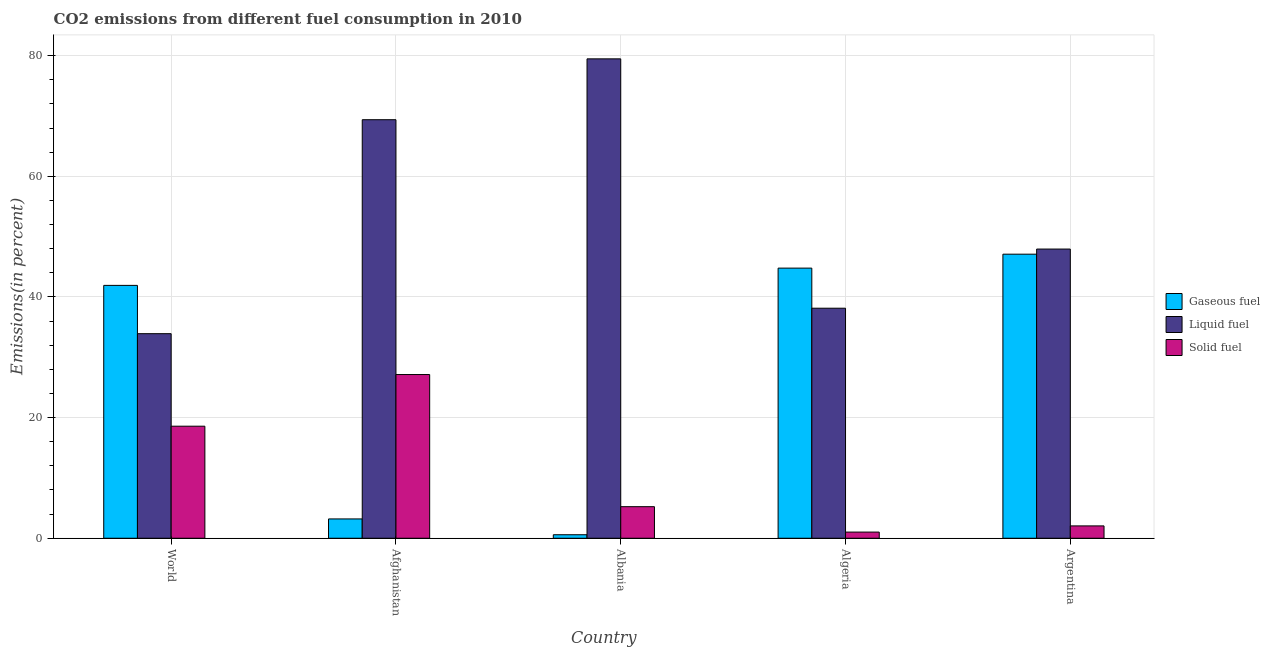How many groups of bars are there?
Provide a short and direct response. 5. Are the number of bars on each tick of the X-axis equal?
Make the answer very short. Yes. What is the percentage of gaseous fuel emission in Argentina?
Ensure brevity in your answer.  47.1. Across all countries, what is the maximum percentage of liquid fuel emission?
Offer a terse response. 79.49. Across all countries, what is the minimum percentage of gaseous fuel emission?
Offer a very short reply. 0.58. In which country was the percentage of solid fuel emission maximum?
Your answer should be compact. Afghanistan. In which country was the percentage of liquid fuel emission minimum?
Your answer should be compact. World. What is the total percentage of liquid fuel emission in the graph?
Offer a very short reply. 268.88. What is the difference between the percentage of gaseous fuel emission in Albania and that in Algeria?
Offer a very short reply. -44.21. What is the difference between the percentage of solid fuel emission in Argentina and the percentage of gaseous fuel emission in Albania?
Keep it short and to the point. 1.47. What is the average percentage of gaseous fuel emission per country?
Keep it short and to the point. 27.52. What is the difference between the percentage of liquid fuel emission and percentage of gaseous fuel emission in World?
Provide a succinct answer. -8.01. What is the ratio of the percentage of liquid fuel emission in Afghanistan to that in Algeria?
Keep it short and to the point. 1.82. Is the difference between the percentage of liquid fuel emission in Albania and World greater than the difference between the percentage of gaseous fuel emission in Albania and World?
Offer a terse response. Yes. What is the difference between the highest and the second highest percentage of gaseous fuel emission?
Give a very brief answer. 2.31. What is the difference between the highest and the lowest percentage of liquid fuel emission?
Offer a very short reply. 45.57. What does the 1st bar from the left in Algeria represents?
Offer a terse response. Gaseous fuel. What does the 1st bar from the right in Afghanistan represents?
Your response must be concise. Solid fuel. Are all the bars in the graph horizontal?
Your answer should be compact. No. How many countries are there in the graph?
Offer a terse response. 5. Does the graph contain any zero values?
Your response must be concise. No. Does the graph contain grids?
Your response must be concise. Yes. How are the legend labels stacked?
Your answer should be very brief. Vertical. What is the title of the graph?
Your response must be concise. CO2 emissions from different fuel consumption in 2010. Does "Ages 15-20" appear as one of the legend labels in the graph?
Offer a very short reply. No. What is the label or title of the X-axis?
Keep it short and to the point. Country. What is the label or title of the Y-axis?
Keep it short and to the point. Emissions(in percent). What is the Emissions(in percent) in Gaseous fuel in World?
Offer a terse response. 41.93. What is the Emissions(in percent) in Liquid fuel in World?
Provide a short and direct response. 33.92. What is the Emissions(in percent) in Solid fuel in World?
Offer a terse response. 18.58. What is the Emissions(in percent) of Gaseous fuel in Afghanistan?
Ensure brevity in your answer.  3.2. What is the Emissions(in percent) of Liquid fuel in Afghanistan?
Ensure brevity in your answer.  69.39. What is the Emissions(in percent) of Solid fuel in Afghanistan?
Give a very brief answer. 27.14. What is the Emissions(in percent) of Gaseous fuel in Albania?
Provide a succinct answer. 0.58. What is the Emissions(in percent) of Liquid fuel in Albania?
Offer a terse response. 79.49. What is the Emissions(in percent) of Solid fuel in Albania?
Keep it short and to the point. 5.23. What is the Emissions(in percent) in Gaseous fuel in Algeria?
Provide a short and direct response. 44.79. What is the Emissions(in percent) in Liquid fuel in Algeria?
Make the answer very short. 38.14. What is the Emissions(in percent) of Solid fuel in Algeria?
Give a very brief answer. 1.02. What is the Emissions(in percent) in Gaseous fuel in Argentina?
Provide a succinct answer. 47.1. What is the Emissions(in percent) in Liquid fuel in Argentina?
Your response must be concise. 47.95. What is the Emissions(in percent) of Solid fuel in Argentina?
Give a very brief answer. 2.05. Across all countries, what is the maximum Emissions(in percent) in Gaseous fuel?
Your response must be concise. 47.1. Across all countries, what is the maximum Emissions(in percent) of Liquid fuel?
Give a very brief answer. 79.49. Across all countries, what is the maximum Emissions(in percent) of Solid fuel?
Keep it short and to the point. 27.14. Across all countries, what is the minimum Emissions(in percent) in Gaseous fuel?
Offer a terse response. 0.58. Across all countries, what is the minimum Emissions(in percent) in Liquid fuel?
Give a very brief answer. 33.92. Across all countries, what is the minimum Emissions(in percent) of Solid fuel?
Provide a short and direct response. 1.02. What is the total Emissions(in percent) in Gaseous fuel in the graph?
Offer a terse response. 137.6. What is the total Emissions(in percent) in Liquid fuel in the graph?
Offer a terse response. 268.88. What is the total Emissions(in percent) of Solid fuel in the graph?
Your answer should be compact. 54.02. What is the difference between the Emissions(in percent) in Gaseous fuel in World and that in Afghanistan?
Offer a very short reply. 38.72. What is the difference between the Emissions(in percent) of Liquid fuel in World and that in Afghanistan?
Provide a succinct answer. -35.48. What is the difference between the Emissions(in percent) in Solid fuel in World and that in Afghanistan?
Your answer should be very brief. -8.57. What is the difference between the Emissions(in percent) in Gaseous fuel in World and that in Albania?
Your response must be concise. 41.34. What is the difference between the Emissions(in percent) of Liquid fuel in World and that in Albania?
Keep it short and to the point. -45.57. What is the difference between the Emissions(in percent) of Solid fuel in World and that in Albania?
Keep it short and to the point. 13.35. What is the difference between the Emissions(in percent) of Gaseous fuel in World and that in Algeria?
Provide a succinct answer. -2.86. What is the difference between the Emissions(in percent) of Liquid fuel in World and that in Algeria?
Provide a succinct answer. -4.22. What is the difference between the Emissions(in percent) of Solid fuel in World and that in Algeria?
Your answer should be compact. 17.56. What is the difference between the Emissions(in percent) in Gaseous fuel in World and that in Argentina?
Your answer should be compact. -5.17. What is the difference between the Emissions(in percent) in Liquid fuel in World and that in Argentina?
Offer a terse response. -14.03. What is the difference between the Emissions(in percent) of Solid fuel in World and that in Argentina?
Keep it short and to the point. 16.53. What is the difference between the Emissions(in percent) in Gaseous fuel in Afghanistan and that in Albania?
Your response must be concise. 2.62. What is the difference between the Emissions(in percent) in Liquid fuel in Afghanistan and that in Albania?
Keep it short and to the point. -10.09. What is the difference between the Emissions(in percent) in Solid fuel in Afghanistan and that in Albania?
Your answer should be compact. 21.91. What is the difference between the Emissions(in percent) in Gaseous fuel in Afghanistan and that in Algeria?
Provide a succinct answer. -41.58. What is the difference between the Emissions(in percent) of Liquid fuel in Afghanistan and that in Algeria?
Your response must be concise. 31.25. What is the difference between the Emissions(in percent) in Solid fuel in Afghanistan and that in Algeria?
Provide a succinct answer. 26.12. What is the difference between the Emissions(in percent) in Gaseous fuel in Afghanistan and that in Argentina?
Offer a very short reply. -43.9. What is the difference between the Emissions(in percent) in Liquid fuel in Afghanistan and that in Argentina?
Your response must be concise. 21.45. What is the difference between the Emissions(in percent) in Solid fuel in Afghanistan and that in Argentina?
Make the answer very short. 25.1. What is the difference between the Emissions(in percent) of Gaseous fuel in Albania and that in Algeria?
Your response must be concise. -44.21. What is the difference between the Emissions(in percent) of Liquid fuel in Albania and that in Algeria?
Keep it short and to the point. 41.34. What is the difference between the Emissions(in percent) of Solid fuel in Albania and that in Algeria?
Your answer should be very brief. 4.21. What is the difference between the Emissions(in percent) in Gaseous fuel in Albania and that in Argentina?
Your answer should be compact. -46.52. What is the difference between the Emissions(in percent) of Liquid fuel in Albania and that in Argentina?
Provide a succinct answer. 31.54. What is the difference between the Emissions(in percent) in Solid fuel in Albania and that in Argentina?
Ensure brevity in your answer.  3.19. What is the difference between the Emissions(in percent) of Gaseous fuel in Algeria and that in Argentina?
Make the answer very short. -2.31. What is the difference between the Emissions(in percent) of Liquid fuel in Algeria and that in Argentina?
Offer a very short reply. -9.81. What is the difference between the Emissions(in percent) in Solid fuel in Algeria and that in Argentina?
Give a very brief answer. -1.03. What is the difference between the Emissions(in percent) in Gaseous fuel in World and the Emissions(in percent) in Liquid fuel in Afghanistan?
Keep it short and to the point. -27.47. What is the difference between the Emissions(in percent) in Gaseous fuel in World and the Emissions(in percent) in Solid fuel in Afghanistan?
Ensure brevity in your answer.  14.78. What is the difference between the Emissions(in percent) in Liquid fuel in World and the Emissions(in percent) in Solid fuel in Afghanistan?
Offer a very short reply. 6.77. What is the difference between the Emissions(in percent) in Gaseous fuel in World and the Emissions(in percent) in Liquid fuel in Albania?
Offer a very short reply. -37.56. What is the difference between the Emissions(in percent) in Gaseous fuel in World and the Emissions(in percent) in Solid fuel in Albania?
Offer a terse response. 36.69. What is the difference between the Emissions(in percent) in Liquid fuel in World and the Emissions(in percent) in Solid fuel in Albania?
Your answer should be compact. 28.68. What is the difference between the Emissions(in percent) of Gaseous fuel in World and the Emissions(in percent) of Liquid fuel in Algeria?
Your response must be concise. 3.79. What is the difference between the Emissions(in percent) in Gaseous fuel in World and the Emissions(in percent) in Solid fuel in Algeria?
Your response must be concise. 40.9. What is the difference between the Emissions(in percent) of Liquid fuel in World and the Emissions(in percent) of Solid fuel in Algeria?
Keep it short and to the point. 32.9. What is the difference between the Emissions(in percent) in Gaseous fuel in World and the Emissions(in percent) in Liquid fuel in Argentina?
Make the answer very short. -6.02. What is the difference between the Emissions(in percent) in Gaseous fuel in World and the Emissions(in percent) in Solid fuel in Argentina?
Your response must be concise. 39.88. What is the difference between the Emissions(in percent) in Liquid fuel in World and the Emissions(in percent) in Solid fuel in Argentina?
Give a very brief answer. 31.87. What is the difference between the Emissions(in percent) in Gaseous fuel in Afghanistan and the Emissions(in percent) in Liquid fuel in Albania?
Offer a very short reply. -76.28. What is the difference between the Emissions(in percent) in Gaseous fuel in Afghanistan and the Emissions(in percent) in Solid fuel in Albania?
Your answer should be compact. -2.03. What is the difference between the Emissions(in percent) of Liquid fuel in Afghanistan and the Emissions(in percent) of Solid fuel in Albania?
Ensure brevity in your answer.  64.16. What is the difference between the Emissions(in percent) in Gaseous fuel in Afghanistan and the Emissions(in percent) in Liquid fuel in Algeria?
Your response must be concise. -34.94. What is the difference between the Emissions(in percent) of Gaseous fuel in Afghanistan and the Emissions(in percent) of Solid fuel in Algeria?
Your answer should be compact. 2.18. What is the difference between the Emissions(in percent) in Liquid fuel in Afghanistan and the Emissions(in percent) in Solid fuel in Algeria?
Your answer should be very brief. 68.37. What is the difference between the Emissions(in percent) of Gaseous fuel in Afghanistan and the Emissions(in percent) of Liquid fuel in Argentina?
Provide a short and direct response. -44.74. What is the difference between the Emissions(in percent) in Gaseous fuel in Afghanistan and the Emissions(in percent) in Solid fuel in Argentina?
Make the answer very short. 1.16. What is the difference between the Emissions(in percent) of Liquid fuel in Afghanistan and the Emissions(in percent) of Solid fuel in Argentina?
Ensure brevity in your answer.  67.35. What is the difference between the Emissions(in percent) in Gaseous fuel in Albania and the Emissions(in percent) in Liquid fuel in Algeria?
Provide a succinct answer. -37.56. What is the difference between the Emissions(in percent) in Gaseous fuel in Albania and the Emissions(in percent) in Solid fuel in Algeria?
Make the answer very short. -0.44. What is the difference between the Emissions(in percent) of Liquid fuel in Albania and the Emissions(in percent) of Solid fuel in Algeria?
Your answer should be very brief. 78.46. What is the difference between the Emissions(in percent) in Gaseous fuel in Albania and the Emissions(in percent) in Liquid fuel in Argentina?
Ensure brevity in your answer.  -47.37. What is the difference between the Emissions(in percent) in Gaseous fuel in Albania and the Emissions(in percent) in Solid fuel in Argentina?
Your answer should be very brief. -1.47. What is the difference between the Emissions(in percent) of Liquid fuel in Albania and the Emissions(in percent) of Solid fuel in Argentina?
Provide a short and direct response. 77.44. What is the difference between the Emissions(in percent) of Gaseous fuel in Algeria and the Emissions(in percent) of Liquid fuel in Argentina?
Ensure brevity in your answer.  -3.16. What is the difference between the Emissions(in percent) in Gaseous fuel in Algeria and the Emissions(in percent) in Solid fuel in Argentina?
Give a very brief answer. 42.74. What is the difference between the Emissions(in percent) of Liquid fuel in Algeria and the Emissions(in percent) of Solid fuel in Argentina?
Give a very brief answer. 36.09. What is the average Emissions(in percent) in Gaseous fuel per country?
Keep it short and to the point. 27.52. What is the average Emissions(in percent) of Liquid fuel per country?
Your response must be concise. 53.78. What is the average Emissions(in percent) in Solid fuel per country?
Keep it short and to the point. 10.8. What is the difference between the Emissions(in percent) of Gaseous fuel and Emissions(in percent) of Liquid fuel in World?
Provide a short and direct response. 8.01. What is the difference between the Emissions(in percent) in Gaseous fuel and Emissions(in percent) in Solid fuel in World?
Offer a terse response. 23.35. What is the difference between the Emissions(in percent) of Liquid fuel and Emissions(in percent) of Solid fuel in World?
Keep it short and to the point. 15.34. What is the difference between the Emissions(in percent) in Gaseous fuel and Emissions(in percent) in Liquid fuel in Afghanistan?
Provide a succinct answer. -66.19. What is the difference between the Emissions(in percent) in Gaseous fuel and Emissions(in percent) in Solid fuel in Afghanistan?
Offer a terse response. -23.94. What is the difference between the Emissions(in percent) in Liquid fuel and Emissions(in percent) in Solid fuel in Afghanistan?
Provide a short and direct response. 42.25. What is the difference between the Emissions(in percent) in Gaseous fuel and Emissions(in percent) in Liquid fuel in Albania?
Your response must be concise. -78.9. What is the difference between the Emissions(in percent) in Gaseous fuel and Emissions(in percent) in Solid fuel in Albania?
Make the answer very short. -4.65. What is the difference between the Emissions(in percent) of Liquid fuel and Emissions(in percent) of Solid fuel in Albania?
Provide a succinct answer. 74.25. What is the difference between the Emissions(in percent) of Gaseous fuel and Emissions(in percent) of Liquid fuel in Algeria?
Offer a very short reply. 6.65. What is the difference between the Emissions(in percent) of Gaseous fuel and Emissions(in percent) of Solid fuel in Algeria?
Make the answer very short. 43.77. What is the difference between the Emissions(in percent) of Liquid fuel and Emissions(in percent) of Solid fuel in Algeria?
Your answer should be very brief. 37.12. What is the difference between the Emissions(in percent) in Gaseous fuel and Emissions(in percent) in Liquid fuel in Argentina?
Offer a very short reply. -0.85. What is the difference between the Emissions(in percent) in Gaseous fuel and Emissions(in percent) in Solid fuel in Argentina?
Offer a very short reply. 45.05. What is the difference between the Emissions(in percent) in Liquid fuel and Emissions(in percent) in Solid fuel in Argentina?
Your answer should be compact. 45.9. What is the ratio of the Emissions(in percent) of Gaseous fuel in World to that in Afghanistan?
Provide a short and direct response. 13.09. What is the ratio of the Emissions(in percent) in Liquid fuel in World to that in Afghanistan?
Give a very brief answer. 0.49. What is the ratio of the Emissions(in percent) in Solid fuel in World to that in Afghanistan?
Offer a very short reply. 0.68. What is the ratio of the Emissions(in percent) in Gaseous fuel in World to that in Albania?
Offer a very short reply. 72.11. What is the ratio of the Emissions(in percent) in Liquid fuel in World to that in Albania?
Keep it short and to the point. 0.43. What is the ratio of the Emissions(in percent) in Solid fuel in World to that in Albania?
Provide a succinct answer. 3.55. What is the ratio of the Emissions(in percent) in Gaseous fuel in World to that in Algeria?
Provide a short and direct response. 0.94. What is the ratio of the Emissions(in percent) of Liquid fuel in World to that in Algeria?
Ensure brevity in your answer.  0.89. What is the ratio of the Emissions(in percent) of Solid fuel in World to that in Algeria?
Make the answer very short. 18.2. What is the ratio of the Emissions(in percent) in Gaseous fuel in World to that in Argentina?
Provide a short and direct response. 0.89. What is the ratio of the Emissions(in percent) of Liquid fuel in World to that in Argentina?
Provide a succinct answer. 0.71. What is the ratio of the Emissions(in percent) in Solid fuel in World to that in Argentina?
Make the answer very short. 9.08. What is the ratio of the Emissions(in percent) in Gaseous fuel in Afghanistan to that in Albania?
Offer a terse response. 5.51. What is the ratio of the Emissions(in percent) of Liquid fuel in Afghanistan to that in Albania?
Give a very brief answer. 0.87. What is the ratio of the Emissions(in percent) in Solid fuel in Afghanistan to that in Albania?
Provide a short and direct response. 5.19. What is the ratio of the Emissions(in percent) of Gaseous fuel in Afghanistan to that in Algeria?
Your answer should be very brief. 0.07. What is the ratio of the Emissions(in percent) in Liquid fuel in Afghanistan to that in Algeria?
Give a very brief answer. 1.82. What is the ratio of the Emissions(in percent) in Solid fuel in Afghanistan to that in Algeria?
Make the answer very short. 26.59. What is the ratio of the Emissions(in percent) of Gaseous fuel in Afghanistan to that in Argentina?
Provide a succinct answer. 0.07. What is the ratio of the Emissions(in percent) of Liquid fuel in Afghanistan to that in Argentina?
Make the answer very short. 1.45. What is the ratio of the Emissions(in percent) of Solid fuel in Afghanistan to that in Argentina?
Offer a very short reply. 13.26. What is the ratio of the Emissions(in percent) of Gaseous fuel in Albania to that in Algeria?
Keep it short and to the point. 0.01. What is the ratio of the Emissions(in percent) of Liquid fuel in Albania to that in Algeria?
Ensure brevity in your answer.  2.08. What is the ratio of the Emissions(in percent) in Solid fuel in Albania to that in Algeria?
Make the answer very short. 5.13. What is the ratio of the Emissions(in percent) in Gaseous fuel in Albania to that in Argentina?
Offer a very short reply. 0.01. What is the ratio of the Emissions(in percent) in Liquid fuel in Albania to that in Argentina?
Offer a terse response. 1.66. What is the ratio of the Emissions(in percent) of Solid fuel in Albania to that in Argentina?
Ensure brevity in your answer.  2.56. What is the ratio of the Emissions(in percent) in Gaseous fuel in Algeria to that in Argentina?
Give a very brief answer. 0.95. What is the ratio of the Emissions(in percent) of Liquid fuel in Algeria to that in Argentina?
Offer a very short reply. 0.8. What is the ratio of the Emissions(in percent) in Solid fuel in Algeria to that in Argentina?
Provide a succinct answer. 0.5. What is the difference between the highest and the second highest Emissions(in percent) in Gaseous fuel?
Offer a very short reply. 2.31. What is the difference between the highest and the second highest Emissions(in percent) of Liquid fuel?
Provide a succinct answer. 10.09. What is the difference between the highest and the second highest Emissions(in percent) in Solid fuel?
Provide a succinct answer. 8.57. What is the difference between the highest and the lowest Emissions(in percent) of Gaseous fuel?
Your response must be concise. 46.52. What is the difference between the highest and the lowest Emissions(in percent) in Liquid fuel?
Offer a very short reply. 45.57. What is the difference between the highest and the lowest Emissions(in percent) in Solid fuel?
Offer a terse response. 26.12. 